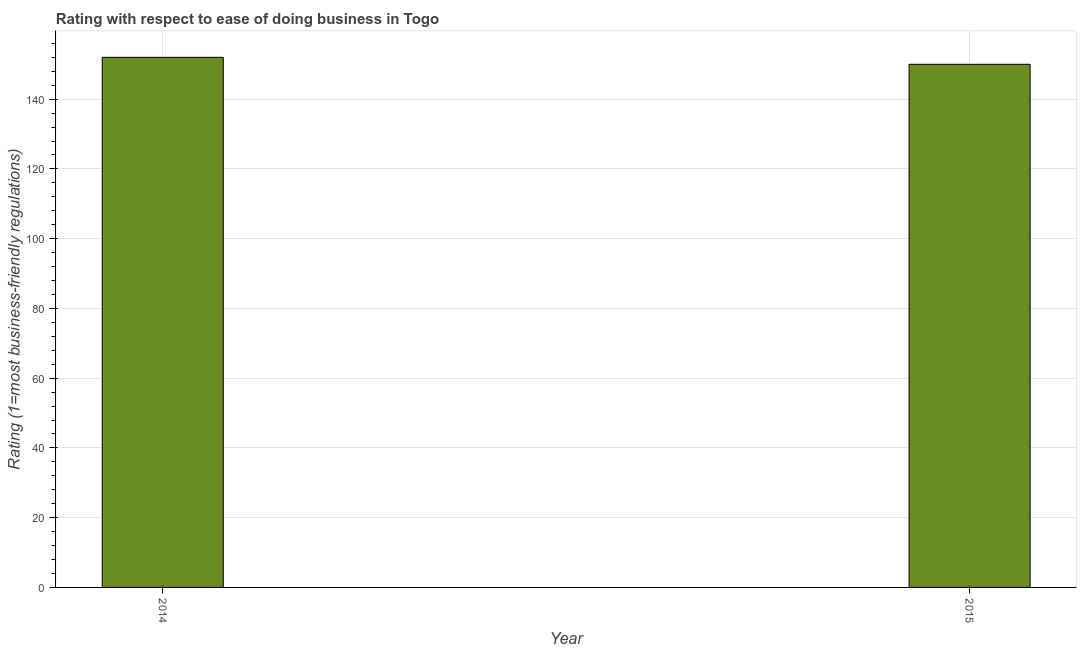Does the graph contain grids?
Ensure brevity in your answer.  Yes. What is the title of the graph?
Offer a terse response. Rating with respect to ease of doing business in Togo. What is the label or title of the X-axis?
Keep it short and to the point. Year. What is the label or title of the Y-axis?
Offer a very short reply. Rating (1=most business-friendly regulations). What is the ease of doing business index in 2015?
Provide a succinct answer. 150. Across all years, what is the maximum ease of doing business index?
Your answer should be compact. 152. Across all years, what is the minimum ease of doing business index?
Offer a very short reply. 150. In which year was the ease of doing business index maximum?
Ensure brevity in your answer.  2014. In which year was the ease of doing business index minimum?
Offer a very short reply. 2015. What is the sum of the ease of doing business index?
Provide a succinct answer. 302. What is the average ease of doing business index per year?
Your response must be concise. 151. What is the median ease of doing business index?
Make the answer very short. 151. Do a majority of the years between 2015 and 2014 (inclusive) have ease of doing business index greater than 140 ?
Your answer should be compact. No. What is the ratio of the ease of doing business index in 2014 to that in 2015?
Give a very brief answer. 1.01. How many bars are there?
Provide a succinct answer. 2. Are all the bars in the graph horizontal?
Ensure brevity in your answer.  No. What is the Rating (1=most business-friendly regulations) of 2014?
Your answer should be compact. 152. What is the Rating (1=most business-friendly regulations) in 2015?
Keep it short and to the point. 150. What is the ratio of the Rating (1=most business-friendly regulations) in 2014 to that in 2015?
Offer a very short reply. 1.01. 